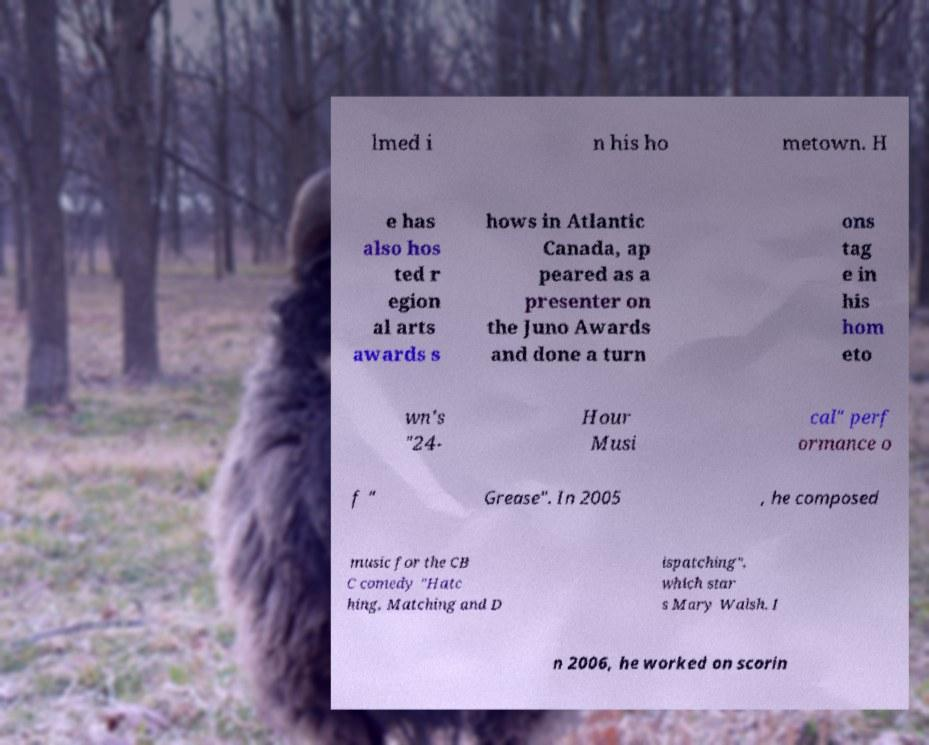For documentation purposes, I need the text within this image transcribed. Could you provide that? lmed i n his ho metown. H e has also hos ted r egion al arts awards s hows in Atlantic Canada, ap peared as a presenter on the Juno Awards and done a turn ons tag e in his hom eto wn's "24- Hour Musi cal" perf ormance o f " Grease". In 2005 , he composed music for the CB C comedy "Hatc hing, Matching and D ispatching", which star s Mary Walsh. I n 2006, he worked on scorin 